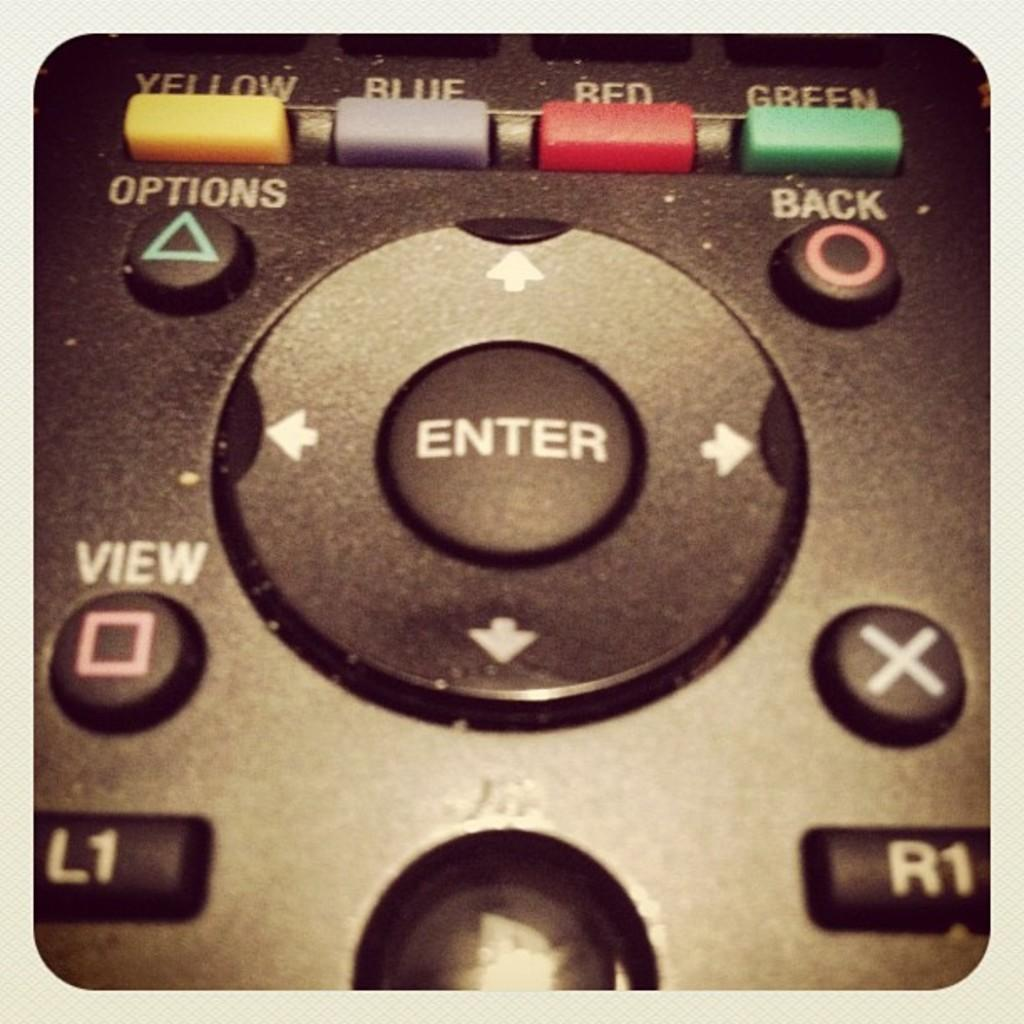<image>
Render a clear and concise summary of the photo. A colse up of an old video game controller with blue, red and green buttons as well as enter and x buttons. 